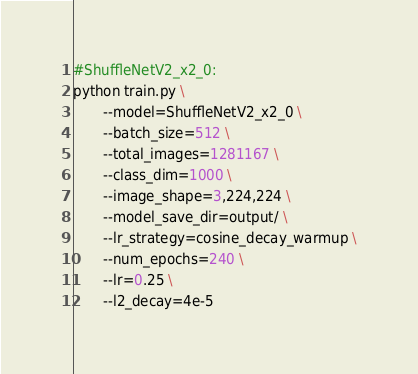Convert code to text. <code><loc_0><loc_0><loc_500><loc_500><_Bash_>#ShuffleNetV2_x2_0:
python train.py \
       --model=ShuffleNetV2_x2_0 \
       --batch_size=512 \
       --total_images=1281167 \
       --class_dim=1000 \
       --image_shape=3,224,224 \
       --model_save_dir=output/ \
       --lr_strategy=cosine_decay_warmup \
       --num_epochs=240 \
       --lr=0.25 \
       --l2_decay=4e-5 
</code> 